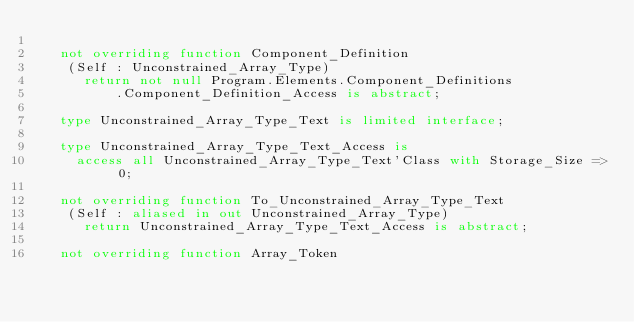Convert code to text. <code><loc_0><loc_0><loc_500><loc_500><_Ada_>
   not overriding function Component_Definition
    (Self : Unconstrained_Array_Type)
      return not null Program.Elements.Component_Definitions
          .Component_Definition_Access is abstract;

   type Unconstrained_Array_Type_Text is limited interface;

   type Unconstrained_Array_Type_Text_Access is
     access all Unconstrained_Array_Type_Text'Class with Storage_Size => 0;

   not overriding function To_Unconstrained_Array_Type_Text
    (Self : aliased in out Unconstrained_Array_Type)
      return Unconstrained_Array_Type_Text_Access is abstract;

   not overriding function Array_Token</code> 